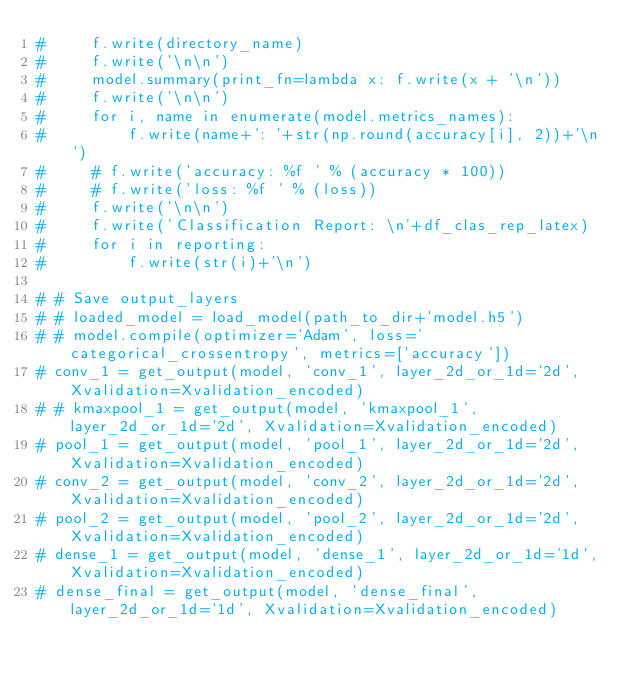<code> <loc_0><loc_0><loc_500><loc_500><_Python_>#     f.write(directory_name)
#     f.write('\n\n')
#     model.summary(print_fn=lambda x: f.write(x + '\n'))
#     f.write('\n\n')
#     for i, name in enumerate(model.metrics_names):
#         f.write(name+': '+str(np.round(accuracy[i], 2))+'\n')
#     # f.write('accuracy: %f ' % (accuracy * 100))
#     # f.write('loss: %f ' % (loss))
#     f.write('\n\n')
#     f.write('Classification Report: \n'+df_clas_rep_latex)
#     for i in reporting:
#         f.write(str(i)+'\n')

# # Save output_layers
# # loaded_model = load_model(path_to_dir+'model.h5')
# # model.compile(optimizer='Adam', loss='categorical_crossentropy', metrics=['accuracy'])
# conv_1 = get_output(model, 'conv_1', layer_2d_or_1d='2d', Xvalidation=Xvalidation_encoded)
# # kmaxpool_1 = get_output(model, 'kmaxpool_1', layer_2d_or_1d='2d', Xvalidation=Xvalidation_encoded)
# pool_1 = get_output(model, 'pool_1', layer_2d_or_1d='2d', Xvalidation=Xvalidation_encoded)
# conv_2 = get_output(model, 'conv_2', layer_2d_or_1d='2d', Xvalidation=Xvalidation_encoded)
# pool_2 = get_output(model, 'pool_2', layer_2d_or_1d='2d', Xvalidation=Xvalidation_encoded)
# dense_1 = get_output(model, 'dense_1', layer_2d_or_1d='1d', Xvalidation=Xvalidation_encoded)
# dense_final = get_output(model, 'dense_final', layer_2d_or_1d='1d', Xvalidation=Xvalidation_encoded)</code> 